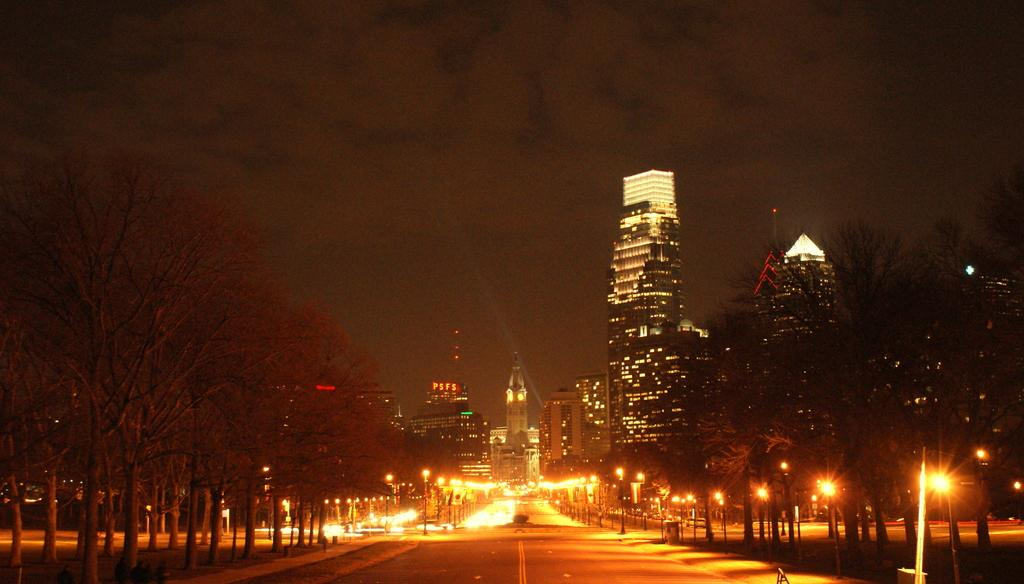What is the main feature of the image? There is a road in the image. What else can be seen along the road? There are lights and poles visible in the image. What type of natural elements are present in the image? There are trees in the image. What can be seen in the background of the image? There is sky and buildings visible in the background of the image. How does the quill balance on the road in the image? There is no quill present in the image, so it cannot be balanced on the road. 